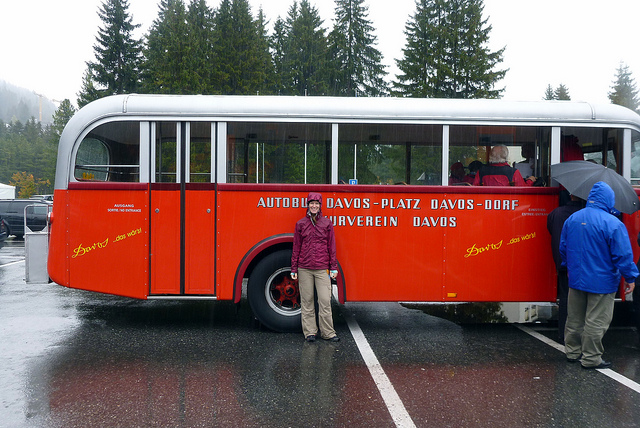Please transcribe the text in this image. AUTOBU DAVOS PLATZ DAVOS DORF DAVOS URVEREIN 